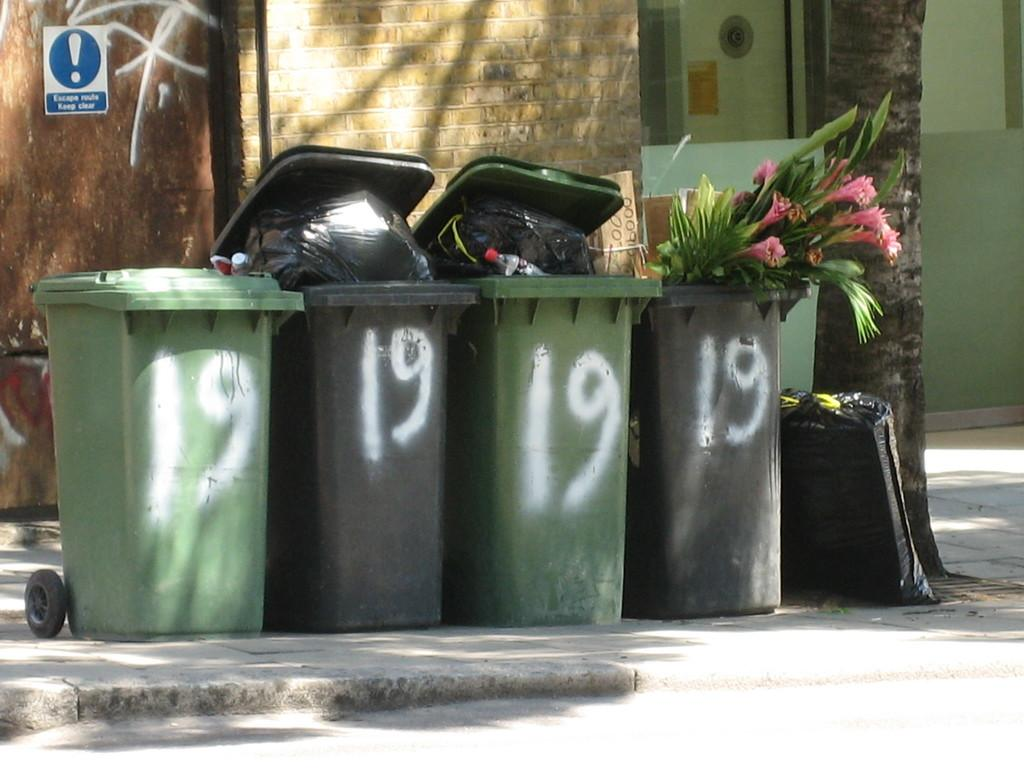Provide a one-sentence caption for the provided image. The number 19 on a bunch of different trashbags. 